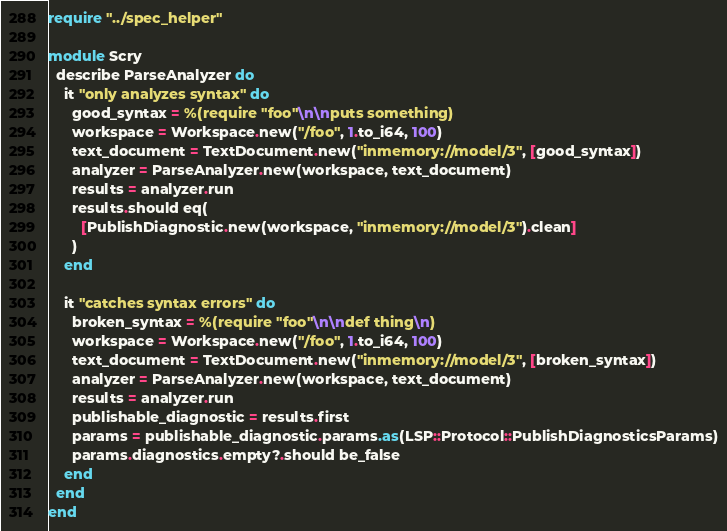<code> <loc_0><loc_0><loc_500><loc_500><_Crystal_>require "../spec_helper"

module Scry
  describe ParseAnalyzer do
    it "only analyzes syntax" do
      good_syntax = %(require "foo"\n\nputs something)
      workspace = Workspace.new("/foo", 1.to_i64, 100)
      text_document = TextDocument.new("inmemory://model/3", [good_syntax])
      analyzer = ParseAnalyzer.new(workspace, text_document)
      results = analyzer.run
      results.should eq(
        [PublishDiagnostic.new(workspace, "inmemory://model/3").clean]
      )
    end

    it "catches syntax errors" do
      broken_syntax = %(require "foo"\n\ndef thing\n)
      workspace = Workspace.new("/foo", 1.to_i64, 100)
      text_document = TextDocument.new("inmemory://model/3", [broken_syntax])
      analyzer = ParseAnalyzer.new(workspace, text_document)
      results = analyzer.run
      publishable_diagnostic = results.first
      params = publishable_diagnostic.params.as(LSP::Protocol::PublishDiagnosticsParams)
      params.diagnostics.empty?.should be_false
    end
  end
end
</code> 